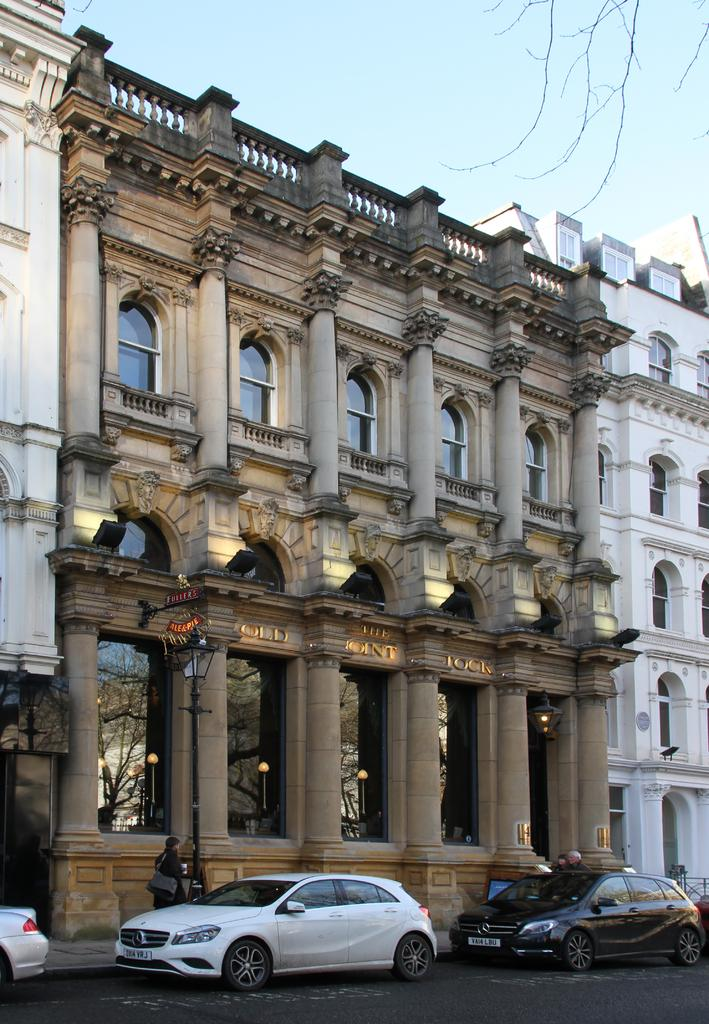What type of structure is visible in the image? There is a building in the image. What can be seen parked near the building? There are cars parked in the image. What are the people in the image doing? There are people standing on the sidewalk in the image. What type of vegetation is visible in the image? There are tree branches visible in the image. How would you describe the weather based on the image? The sky appears to be cloudy in the image. What type of jam is being served on the plate in the image? There is no plate or jam present in the image. 